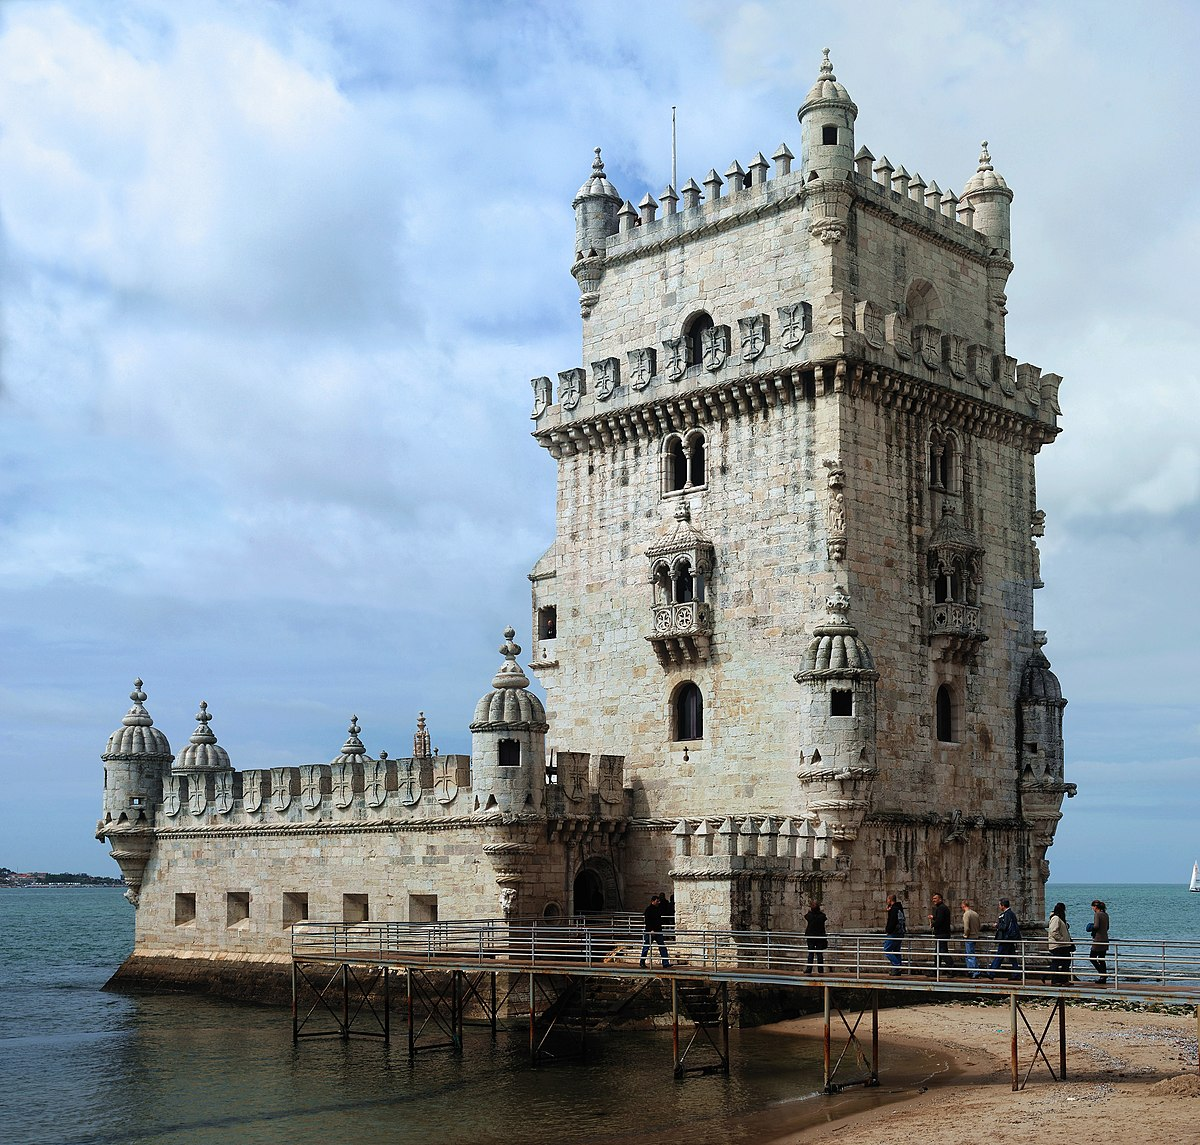Why is the Belem Tower built at the mouth of the Tagus River? The strategic placement of Belem Tower at the mouth of the Tagus River in Lisbon was primarily for defense purposes, serving as a point to guard the entrance to Lisbon's harbor and protect the city from potential seafaring invaders. Additionally, during the Age of Discoveries, it played a crucial role by being a gateway for sailors embarking on voyages, symbolizing the last sight of homeland for those departing into the unknown. 